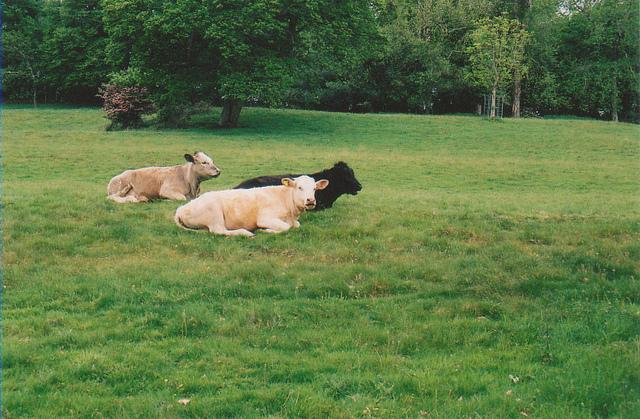What are the cows doing?

Choices:
A) walking
B) laying down
C) playing soccer
D) running laying down 